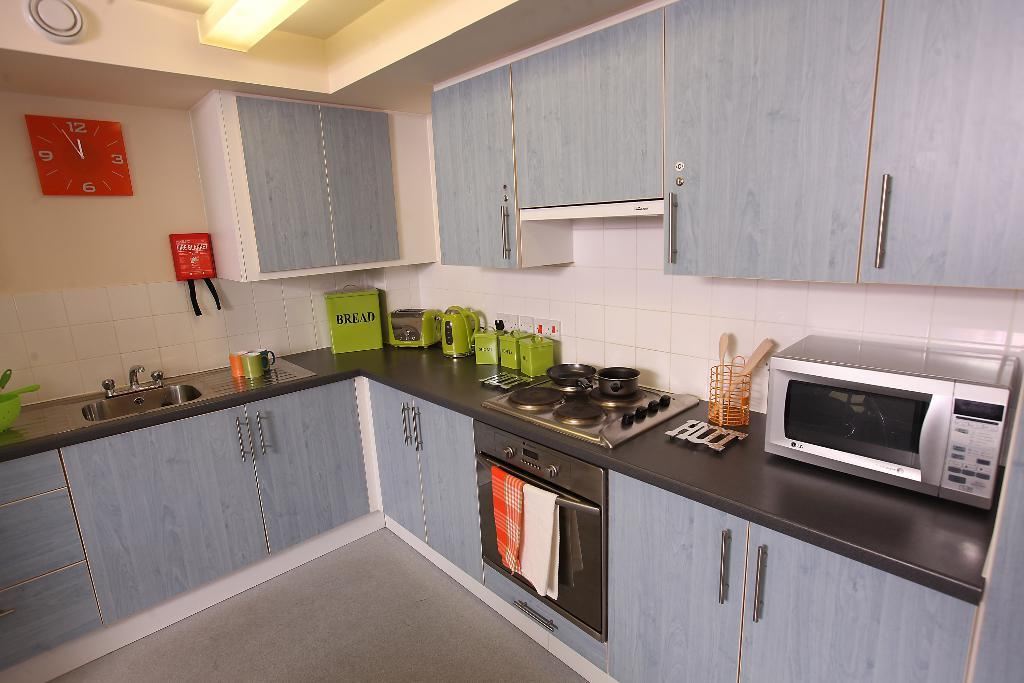<image>
Write a terse but informative summary of the picture. A kitchen with a silver microwave and a green box that says bread. 